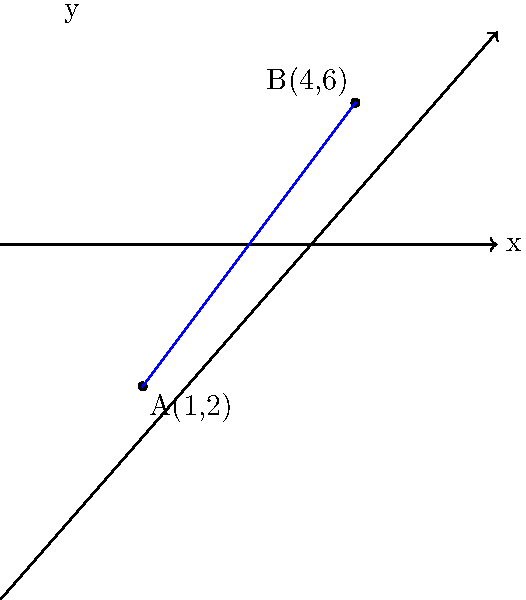As a Java developer, you're working on a program that calculates distances between points in a 2D space. Given two points A(1,2) and B(4,6) on a coordinate plane, write a Java method to calculate the distance between these points. What is the distance between A and B? To find the distance between two points, we can use the distance formula, which is derived from the Pythagorean theorem:

$$d = \sqrt{(x_2 - x_1)^2 + (y_2 - y_1)^2}$$

Where $(x_1, y_1)$ are the coordinates of the first point and $(x_2, y_2)$ are the coordinates of the second point.

Let's solve this step-by-step:

1. Identify the coordinates:
   Point A: $(x_1, y_1) = (1, 2)$
   Point B: $(x_2, y_2) = (4, 6)$

2. Calculate the differences:
   $x_2 - x_1 = 4 - 1 = 3$
   $y_2 - y_1 = 6 - 2 = 4$

3. Square the differences:
   $(x_2 - x_1)^2 = 3^2 = 9$
   $(y_2 - y_1)^2 = 4^2 = 16$

4. Sum the squared differences:
   $(x_2 - x_1)^2 + (y_2 - y_1)^2 = 9 + 16 = 25$

5. Take the square root of the sum:
   $d = \sqrt{25} = 5$

Therefore, the distance between points A and B is 5 units.

In Java, you could implement this as:

```java
public static double calculateDistance(double x1, double y1, double x2, double y2) {
    return Math.sqrt(Math.pow(x2 - x1, 2) + Math.pow(y2 - y1, 2));
}
```

And call it with:

```java
double distance = calculateDistance(1, 2, 4, 6);
```
Answer: 5 units 